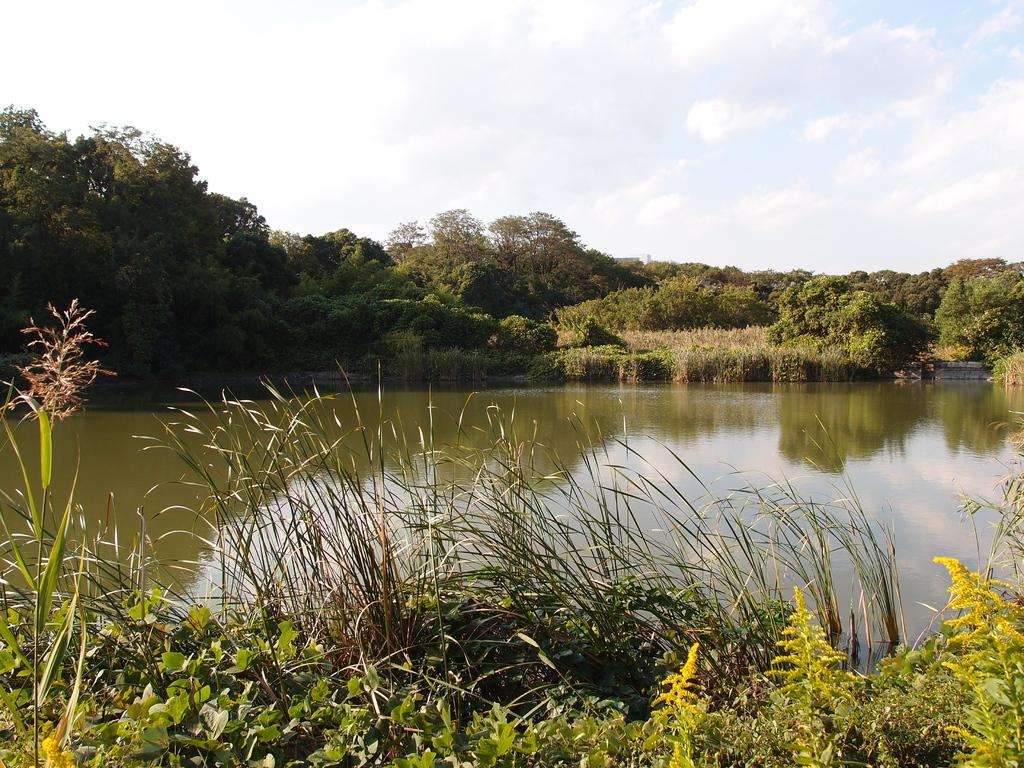What type of vegetation is in the front of the image? There are plants and grass in the front of the image. What body of water can be seen in the image? There is a pond in the image. What type of vegetation is in the background of the image? There are trees on the land in the background of the image. What part of the natural environment is visible in the image? The sky is visible in the image. What can be observed in the sky? Clouds are present in the sky. What type of surprise can be seen falling from the sky in the image? There is no surprise falling from the sky in the image; only clouds are present. What type of texture can be observed on the plants in the image? The provided facts do not mention the texture of the plants, so it cannot be determined from the image. 